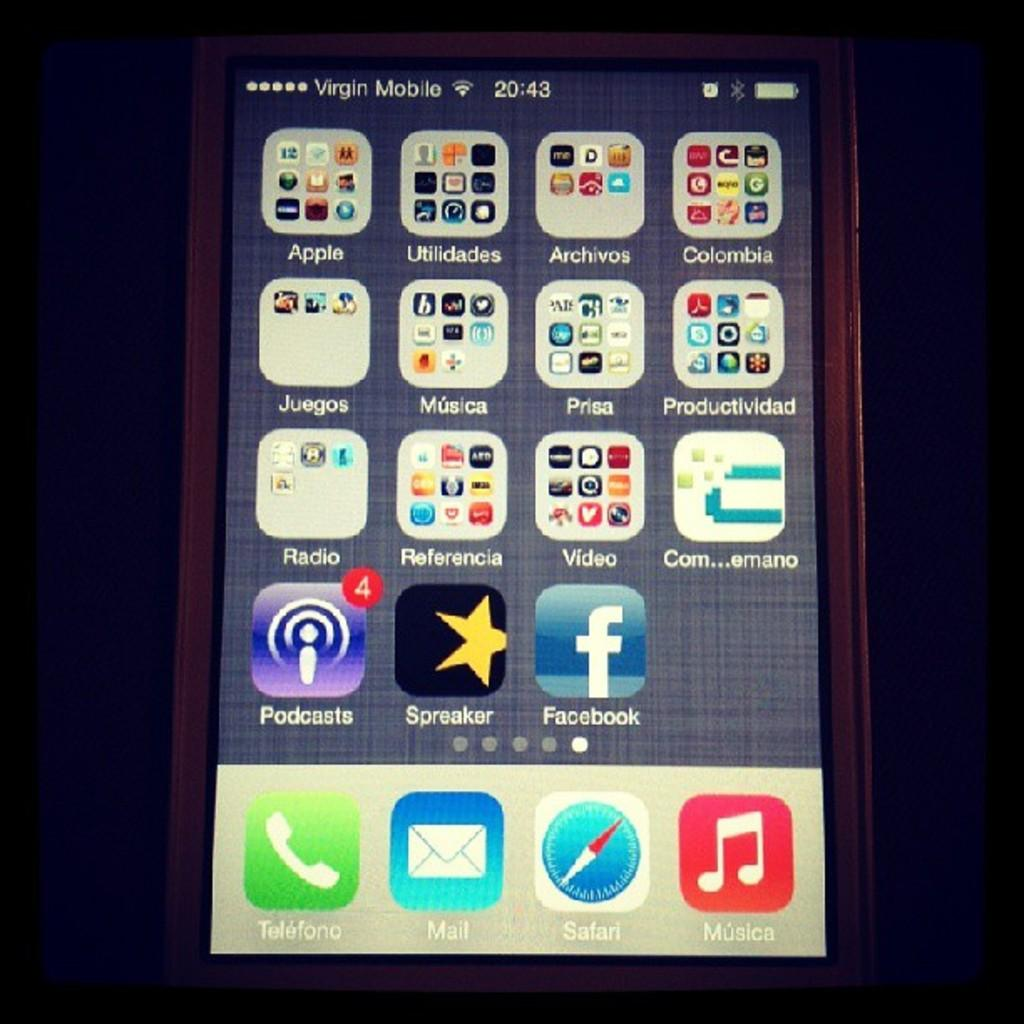<image>
Summarize the visual content of the image. A Virgin Mobile device with the phone icon in the left bottom corner. 